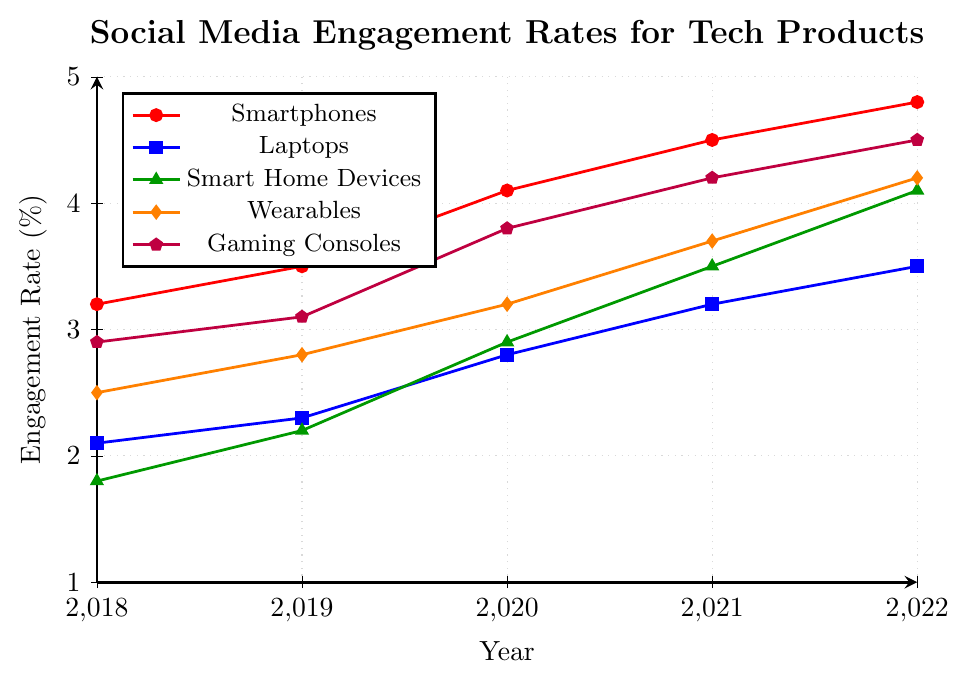What's the highest engagement rate among the tech product categories in 2022? Look at the engagement rates for 2022. The highest rate is 4.8%, which belongs to Smartphones.
Answer: 4.8% Which product category had the lowest engagement rate in 2018? Look at the engagement rates for all categories in 2018: Smartphones (3.2%), Laptops (2.1%), Smart Home Devices (1.8%), Wearables (2.5%), Gaming Consoles (2.9%). The lowest rate is 1.8% for Smart Home Devices.
Answer: Smart Home Devices Between 2018 and 2022, which product category showed the most significant increase in engagement rate? Calculate the difference in engagement rates between 2022 and 2018 for each category: Smartphones (4.8 - 3.2 = 1.6), Laptops (3.5 - 2.1 = 1.4), Smart Home Devices (4.1 - 1.8 = 2.3), Wearables (4.2 - 2.5 = 1.7), Gaming Consoles (4.5 - 2.9 = 1.6). The most significant increase is 2.3% for Smart Home Devices.
Answer: Smart Home Devices What’s the average engagement rate for Gaming Consoles over the 5 years? Add the engagement rates for Gaming Consoles from 2018 to 2022 (2.9 + 3.1 + 3.8 + 4.2 + 4.5) = 18.5 and divide by the number of years (5). The average is 18.5 / 5 = 3.7.
Answer: 3.7 How did the engagement rate for Wearables change from 2019 to 2021? Look at the engagement rates for Wearables in 2019 (2.8) and 2021 (3.7). The change is 3.7 - 2.8 = 0.9.
Answer: Increased by 0.9 Which two categories had the closest engagement rates in 2022? Look at the engagement rates for 2022: Smartphones (4.8), Laptops (3.5), Smart Home Devices (4.1), Wearables (4.2), Gaming Consoles (4.5). Compare the differences: Laptops and Smart Home Devices (4.1 - 3.5 = 0.6), Wearables and Gaming Consoles (4.5 - 4.2 = 0.3), Gaming Consoles and Smart Home Devices (4.5 - 4.1 = 0.4). The closest rates are Wearables (4.2) and Gaming Consoles (4.5) with a difference of 0.3.
Answer: Wearables and Gaming Consoles What product category had the least consistent growth in engagement rate over the 5 years? Analyze the growth patterns by comparing the differences year-over-year for each category. Smartphones: 0.3, 0.6, 0.4, 0.3; Laptops: 0.2, 0.5, 0.4, 0.3; Smart Home Devices: 0.4, 0.7, 0.6; Wearables: 0.3, 0.4, 0.5; Gaming Consoles: 0.2, 0.7, 0.4, 0.3. Laptops and Gaming Consoles show an equal highest variance, but Laptop fluctuations are more distributed across the years.
Answer: Laptops 